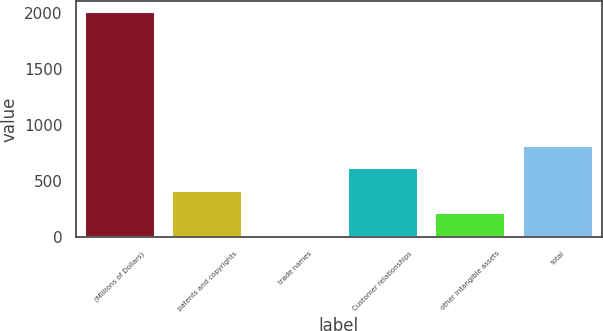<chart> <loc_0><loc_0><loc_500><loc_500><bar_chart><fcel>(Millions of Dollars)<fcel>patents and copyrights<fcel>trade names<fcel>Customer relationships<fcel>other intangible assets<fcel>total<nl><fcel>2006<fcel>413.6<fcel>15.5<fcel>612.65<fcel>214.55<fcel>811.7<nl></chart> 